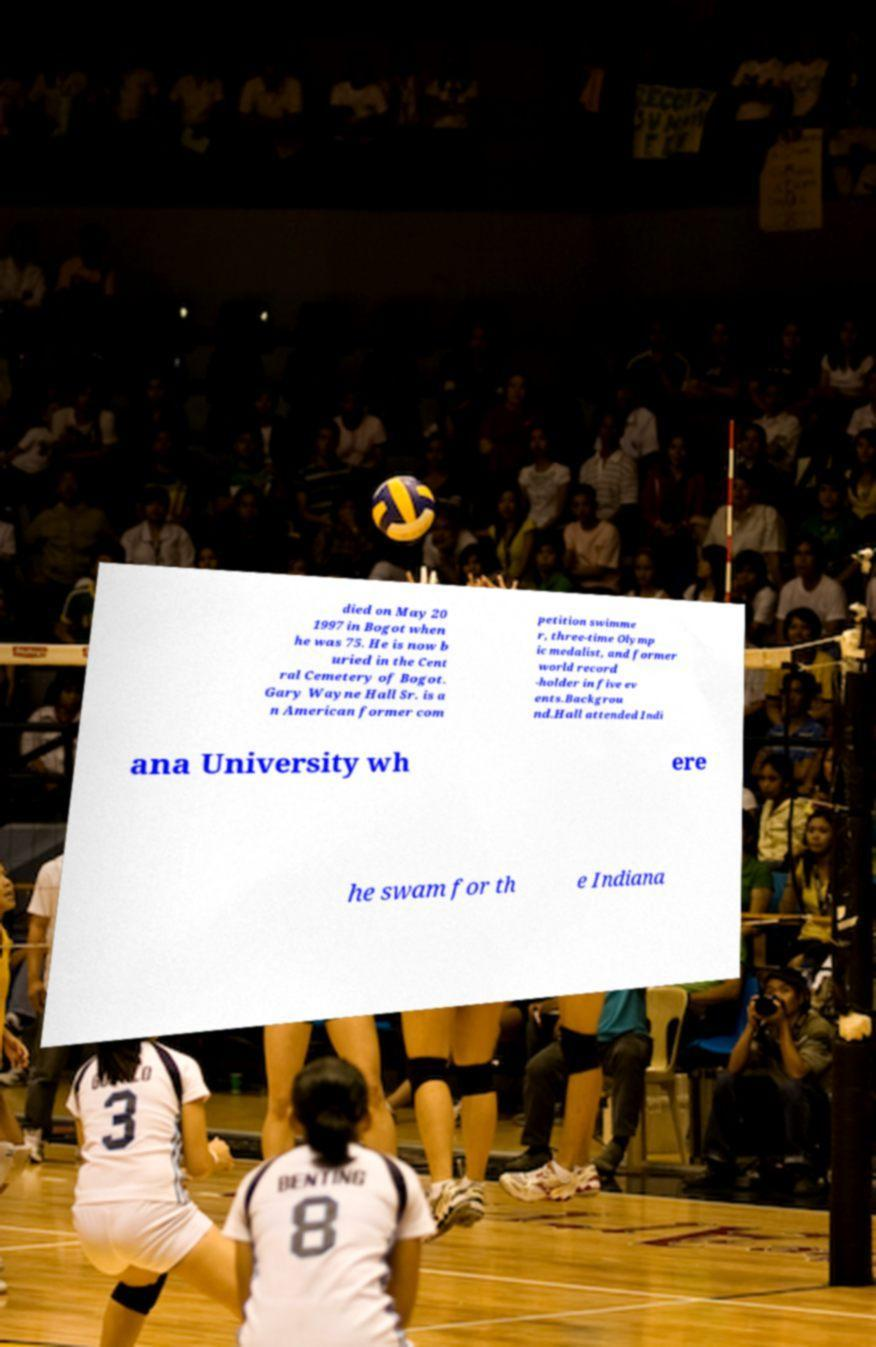There's text embedded in this image that I need extracted. Can you transcribe it verbatim? died on May 20 1997 in Bogot when he was 75. He is now b uried in the Cent ral Cemetery of Bogot. Gary Wayne Hall Sr. is a n American former com petition swimme r, three-time Olymp ic medalist, and former world record -holder in five ev ents.Backgrou nd.Hall attended Indi ana University wh ere he swam for th e Indiana 